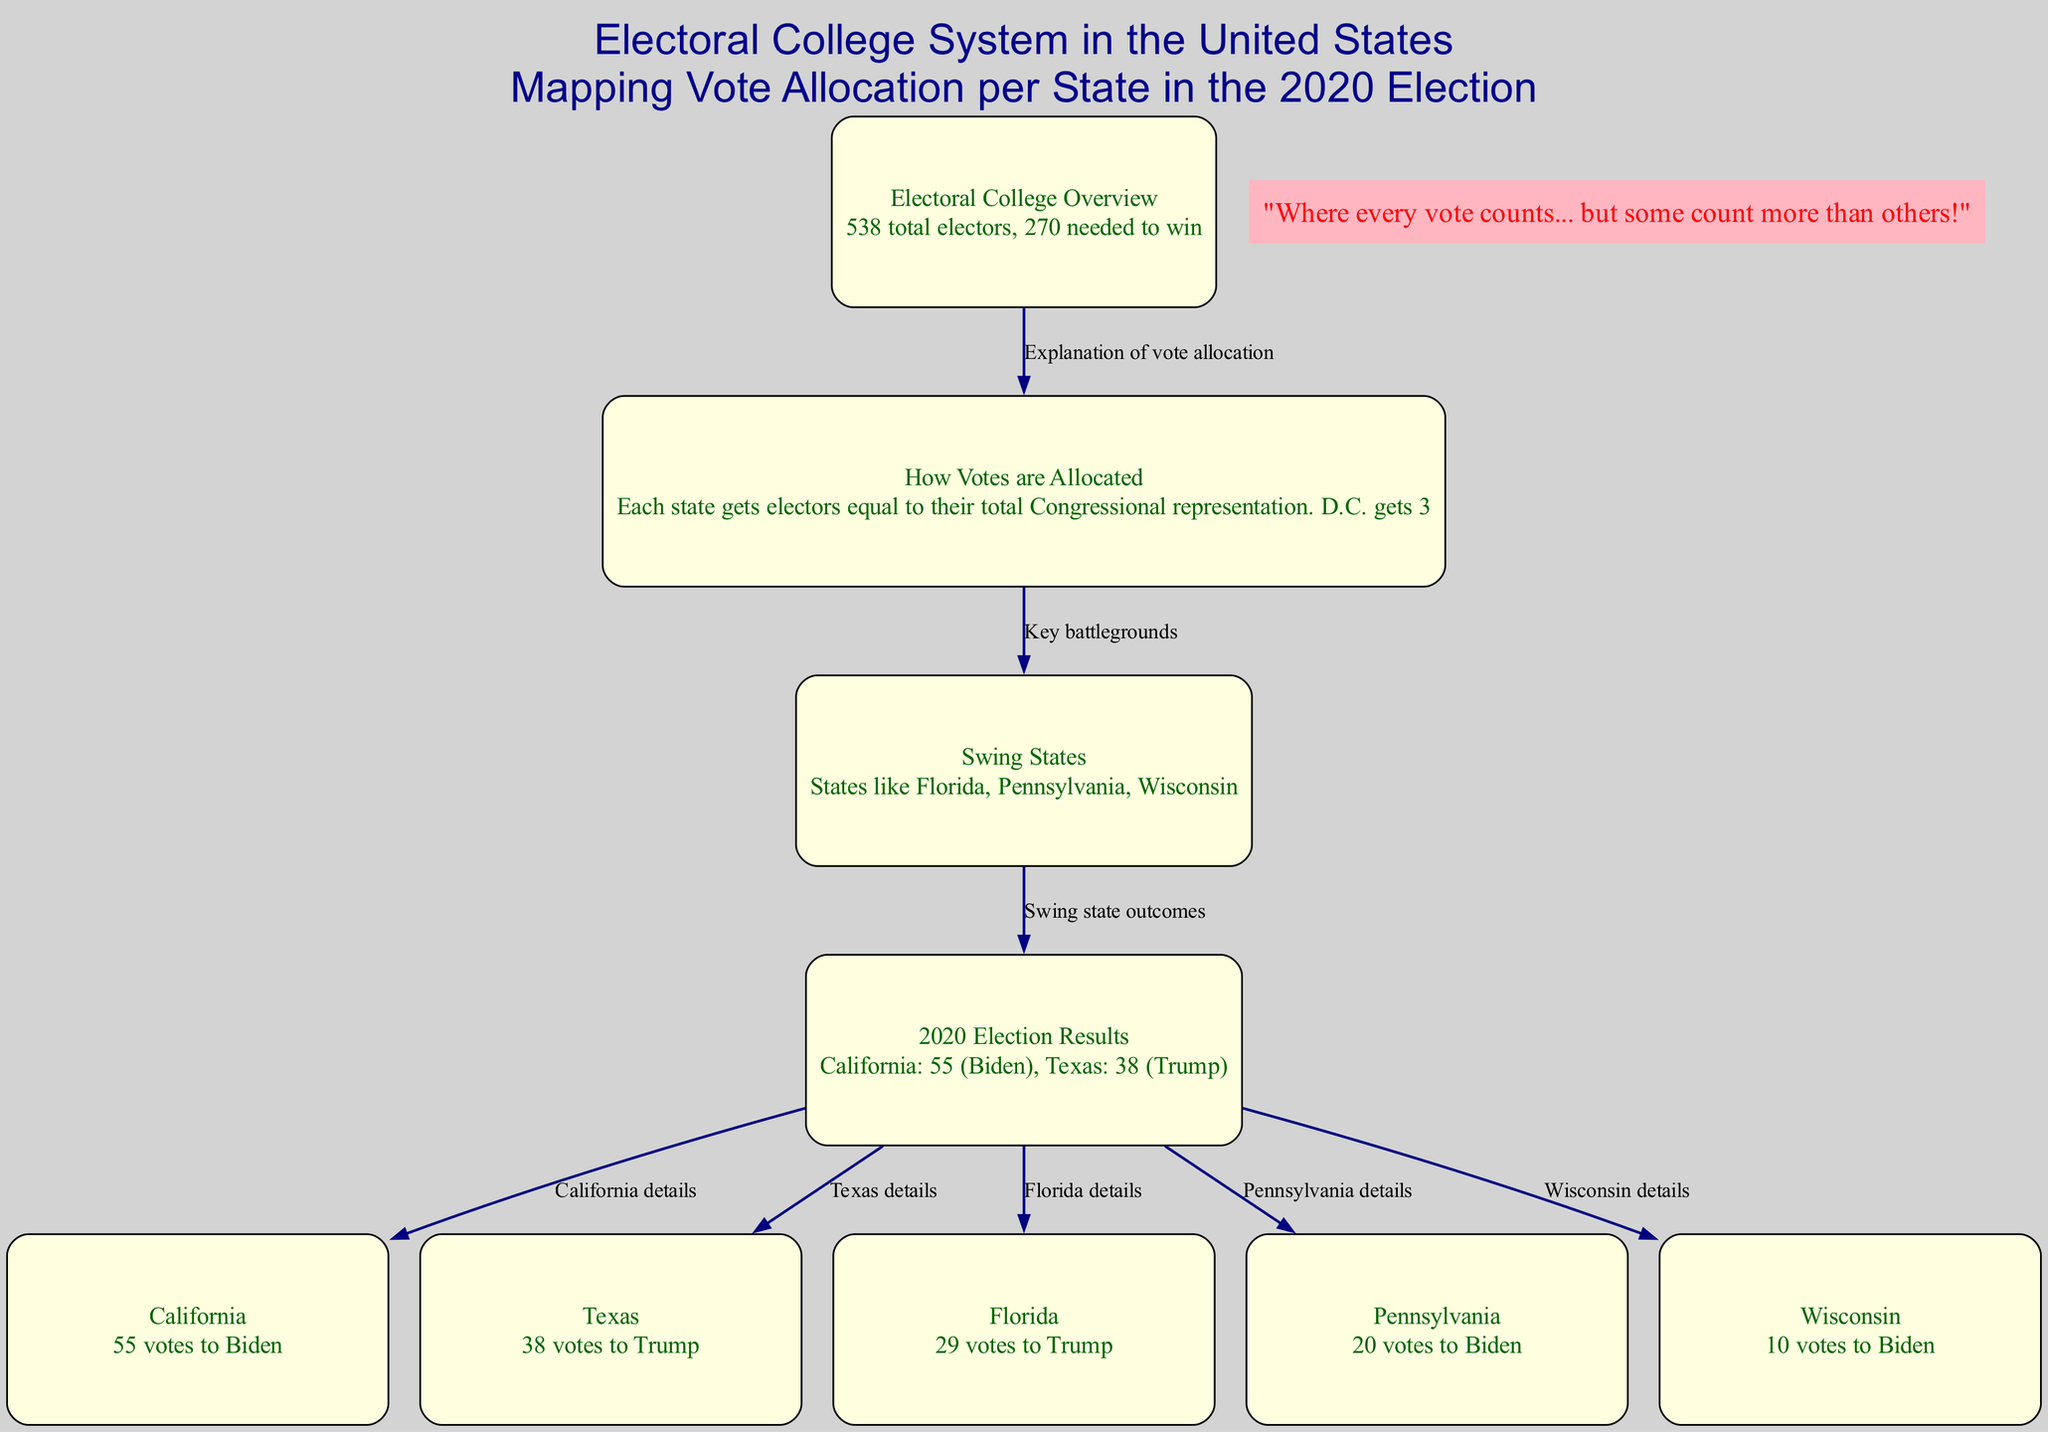What is the total number of electoral votes? The diagram states that there are 538 total electors in the Electoral College System.
Answer: 538 How many votes does California have? According to the diagram, California has 55 electoral votes allocated to Biden.
Answer: 55 Which candidate received votes from Texas? The diagram indicates that Texas allocated its 38 votes to Trump in the election results.
Answer: Trump What is the minimum number of votes needed to win the Electoral College? The diagram explains that 270 electoral votes are needed to win.
Answer: 270 Name one swing state mentioned in the diagram. The diagram lists Florida as one of the swing states in the election.
Answer: Florida How are votes allocated per state? The content specifies that each state's electors are equal to their total Congressional representation, with D.C. getting 3 electors.
Answer: Based on Congressional representation How many electoral votes did Wisconsin allocate? The diagram shows that Wisconsin allocated 10 votes to Biden.
Answer: 10 What relationship is shown between swing states and election results? The edges indicate that the swing states link to the election results, showing which candidates received votes in those states.
Answer: Swing state outcomes Which state has the highest number of electoral votes? The diagram indicates California has the highest number of electoral votes at 55.
Answer: California 